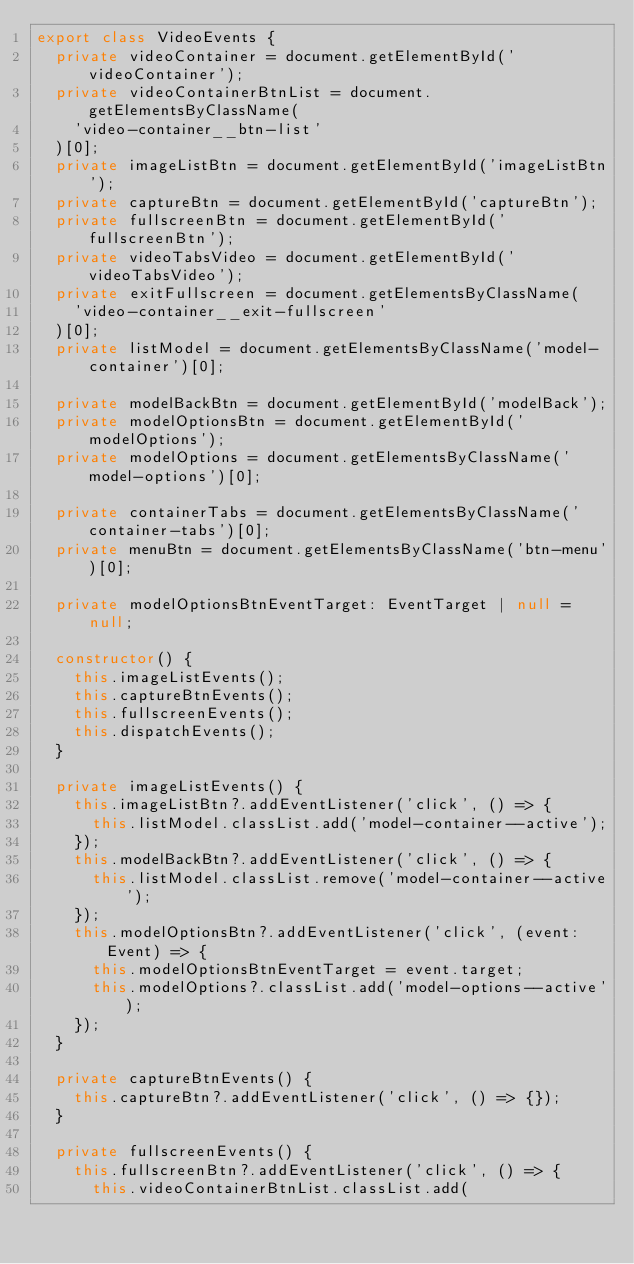<code> <loc_0><loc_0><loc_500><loc_500><_TypeScript_>export class VideoEvents {
  private videoContainer = document.getElementById('videoContainer');
  private videoContainerBtnList = document.getElementsByClassName(
    'video-container__btn-list'
  )[0];
  private imageListBtn = document.getElementById('imageListBtn');
  private captureBtn = document.getElementById('captureBtn');
  private fullscreenBtn = document.getElementById('fullscreenBtn');
  private videoTabsVideo = document.getElementById('videoTabsVideo');
  private exitFullscreen = document.getElementsByClassName(
    'video-container__exit-fullscreen'
  )[0];
  private listModel = document.getElementsByClassName('model-container')[0];

  private modelBackBtn = document.getElementById('modelBack');
  private modelOptionsBtn = document.getElementById('modelOptions');
  private modelOptions = document.getElementsByClassName('model-options')[0];

  private containerTabs = document.getElementsByClassName('container-tabs')[0];
  private menuBtn = document.getElementsByClassName('btn-menu')[0];

  private modelOptionsBtnEventTarget: EventTarget | null = null;

  constructor() {
    this.imageListEvents();
    this.captureBtnEvents();
    this.fullscreenEvents();
    this.dispatchEvents();
  }

  private imageListEvents() {
    this.imageListBtn?.addEventListener('click', () => {
      this.listModel.classList.add('model-container--active');
    });
    this.modelBackBtn?.addEventListener('click', () => {
      this.listModel.classList.remove('model-container--active');
    });
    this.modelOptionsBtn?.addEventListener('click', (event: Event) => {
      this.modelOptionsBtnEventTarget = event.target;
      this.modelOptions?.classList.add('model-options--active');
    });
  }

  private captureBtnEvents() {
    this.captureBtn?.addEventListener('click', () => {});
  }

  private fullscreenEvents() {
    this.fullscreenBtn?.addEventListener('click', () => {
      this.videoContainerBtnList.classList.add(</code> 